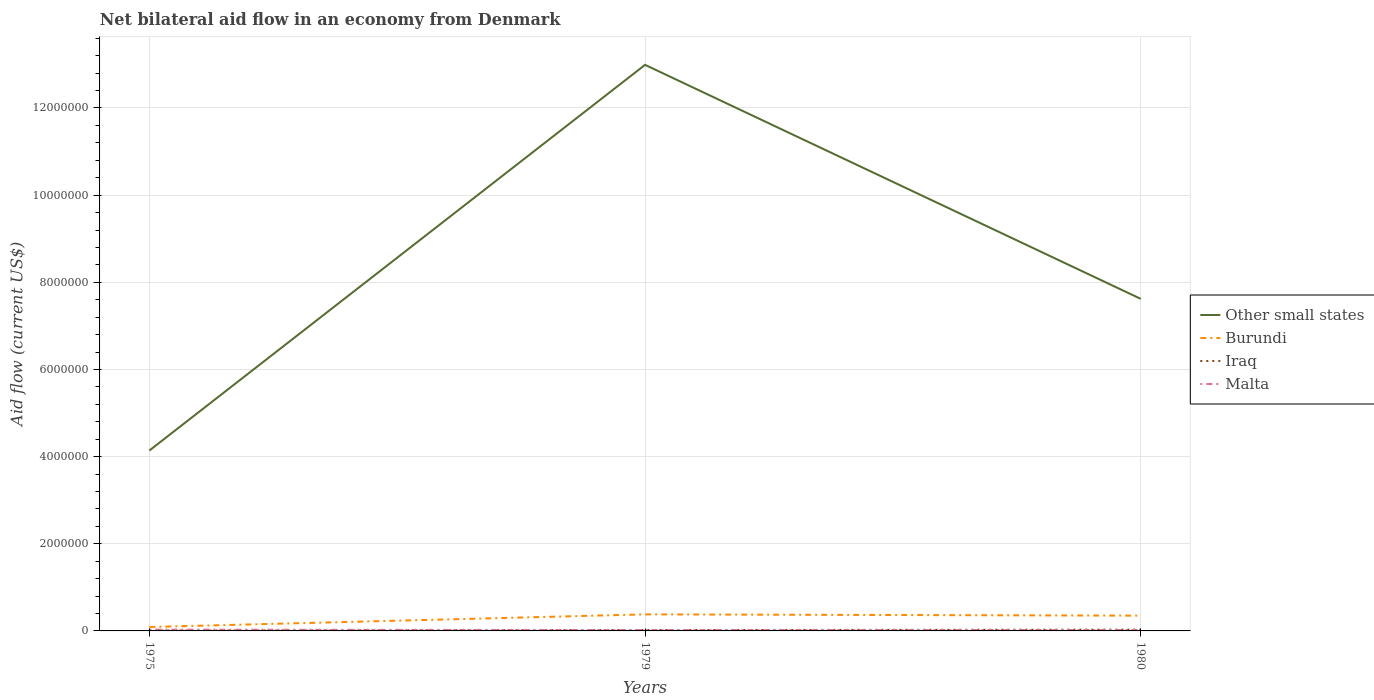How many different coloured lines are there?
Provide a short and direct response. 4. Is the number of lines equal to the number of legend labels?
Your answer should be compact. Yes. Across all years, what is the maximum net bilateral aid flow in Other small states?
Ensure brevity in your answer.  4.14e+06. In which year was the net bilateral aid flow in Burundi maximum?
Provide a succinct answer. 1975. What is the difference between the highest and the second highest net bilateral aid flow in Other small states?
Ensure brevity in your answer.  8.85e+06. Is the net bilateral aid flow in Burundi strictly greater than the net bilateral aid flow in Iraq over the years?
Provide a succinct answer. No. Are the values on the major ticks of Y-axis written in scientific E-notation?
Provide a succinct answer. No. Where does the legend appear in the graph?
Ensure brevity in your answer.  Center right. How many legend labels are there?
Offer a very short reply. 4. What is the title of the graph?
Give a very brief answer. Net bilateral aid flow in an economy from Denmark. What is the label or title of the X-axis?
Ensure brevity in your answer.  Years. What is the label or title of the Y-axis?
Offer a terse response. Aid flow (current US$). What is the Aid flow (current US$) of Other small states in 1975?
Keep it short and to the point. 4.14e+06. What is the Aid flow (current US$) of Burundi in 1975?
Make the answer very short. 9.00e+04. What is the Aid flow (current US$) in Iraq in 1975?
Make the answer very short. 10000. What is the Aid flow (current US$) of Malta in 1975?
Offer a terse response. 3.00e+04. What is the Aid flow (current US$) of Other small states in 1979?
Provide a succinct answer. 1.30e+07. What is the Aid flow (current US$) in Burundi in 1979?
Give a very brief answer. 3.80e+05. What is the Aid flow (current US$) of Iraq in 1979?
Provide a short and direct response. 2.00e+04. What is the Aid flow (current US$) of Other small states in 1980?
Offer a terse response. 7.62e+06. What is the Aid flow (current US$) of Burundi in 1980?
Offer a very short reply. 3.50e+05. Across all years, what is the maximum Aid flow (current US$) of Other small states?
Your answer should be compact. 1.30e+07. Across all years, what is the minimum Aid flow (current US$) of Other small states?
Provide a succinct answer. 4.14e+06. Across all years, what is the minimum Aid flow (current US$) of Burundi?
Offer a terse response. 9.00e+04. Across all years, what is the minimum Aid flow (current US$) in Iraq?
Make the answer very short. 10000. Across all years, what is the minimum Aid flow (current US$) in Malta?
Provide a succinct answer. 2.00e+04. What is the total Aid flow (current US$) in Other small states in the graph?
Offer a very short reply. 2.48e+07. What is the total Aid flow (current US$) in Burundi in the graph?
Ensure brevity in your answer.  8.20e+05. What is the difference between the Aid flow (current US$) of Other small states in 1975 and that in 1979?
Keep it short and to the point. -8.85e+06. What is the difference between the Aid flow (current US$) of Burundi in 1975 and that in 1979?
Keep it short and to the point. -2.90e+05. What is the difference between the Aid flow (current US$) of Iraq in 1975 and that in 1979?
Make the answer very short. -10000. What is the difference between the Aid flow (current US$) of Malta in 1975 and that in 1979?
Provide a short and direct response. 10000. What is the difference between the Aid flow (current US$) of Other small states in 1975 and that in 1980?
Give a very brief answer. -3.48e+06. What is the difference between the Aid flow (current US$) in Burundi in 1975 and that in 1980?
Your answer should be very brief. -2.60e+05. What is the difference between the Aid flow (current US$) in Iraq in 1975 and that in 1980?
Your response must be concise. -2.00e+04. What is the difference between the Aid flow (current US$) of Malta in 1975 and that in 1980?
Keep it short and to the point. 10000. What is the difference between the Aid flow (current US$) in Other small states in 1979 and that in 1980?
Your response must be concise. 5.37e+06. What is the difference between the Aid flow (current US$) of Burundi in 1979 and that in 1980?
Make the answer very short. 3.00e+04. What is the difference between the Aid flow (current US$) of Other small states in 1975 and the Aid flow (current US$) of Burundi in 1979?
Make the answer very short. 3.76e+06. What is the difference between the Aid flow (current US$) of Other small states in 1975 and the Aid flow (current US$) of Iraq in 1979?
Offer a terse response. 4.12e+06. What is the difference between the Aid flow (current US$) in Other small states in 1975 and the Aid flow (current US$) in Malta in 1979?
Provide a short and direct response. 4.12e+06. What is the difference between the Aid flow (current US$) of Burundi in 1975 and the Aid flow (current US$) of Iraq in 1979?
Provide a short and direct response. 7.00e+04. What is the difference between the Aid flow (current US$) of Burundi in 1975 and the Aid flow (current US$) of Malta in 1979?
Ensure brevity in your answer.  7.00e+04. What is the difference between the Aid flow (current US$) of Iraq in 1975 and the Aid flow (current US$) of Malta in 1979?
Offer a very short reply. -10000. What is the difference between the Aid flow (current US$) of Other small states in 1975 and the Aid flow (current US$) of Burundi in 1980?
Offer a terse response. 3.79e+06. What is the difference between the Aid flow (current US$) in Other small states in 1975 and the Aid flow (current US$) in Iraq in 1980?
Make the answer very short. 4.11e+06. What is the difference between the Aid flow (current US$) of Other small states in 1975 and the Aid flow (current US$) of Malta in 1980?
Offer a very short reply. 4.12e+06. What is the difference between the Aid flow (current US$) in Burundi in 1975 and the Aid flow (current US$) in Iraq in 1980?
Offer a terse response. 6.00e+04. What is the difference between the Aid flow (current US$) of Burundi in 1975 and the Aid flow (current US$) of Malta in 1980?
Make the answer very short. 7.00e+04. What is the difference between the Aid flow (current US$) of Other small states in 1979 and the Aid flow (current US$) of Burundi in 1980?
Your answer should be compact. 1.26e+07. What is the difference between the Aid flow (current US$) in Other small states in 1979 and the Aid flow (current US$) in Iraq in 1980?
Keep it short and to the point. 1.30e+07. What is the difference between the Aid flow (current US$) of Other small states in 1979 and the Aid flow (current US$) of Malta in 1980?
Provide a succinct answer. 1.30e+07. What is the difference between the Aid flow (current US$) in Burundi in 1979 and the Aid flow (current US$) in Iraq in 1980?
Give a very brief answer. 3.50e+05. What is the difference between the Aid flow (current US$) in Burundi in 1979 and the Aid flow (current US$) in Malta in 1980?
Provide a short and direct response. 3.60e+05. What is the average Aid flow (current US$) in Other small states per year?
Your response must be concise. 8.25e+06. What is the average Aid flow (current US$) of Burundi per year?
Offer a very short reply. 2.73e+05. What is the average Aid flow (current US$) in Iraq per year?
Offer a terse response. 2.00e+04. What is the average Aid flow (current US$) in Malta per year?
Offer a terse response. 2.33e+04. In the year 1975, what is the difference between the Aid flow (current US$) in Other small states and Aid flow (current US$) in Burundi?
Your answer should be very brief. 4.05e+06. In the year 1975, what is the difference between the Aid flow (current US$) in Other small states and Aid flow (current US$) in Iraq?
Provide a succinct answer. 4.13e+06. In the year 1975, what is the difference between the Aid flow (current US$) of Other small states and Aid flow (current US$) of Malta?
Your response must be concise. 4.11e+06. In the year 1975, what is the difference between the Aid flow (current US$) in Iraq and Aid flow (current US$) in Malta?
Give a very brief answer. -2.00e+04. In the year 1979, what is the difference between the Aid flow (current US$) in Other small states and Aid flow (current US$) in Burundi?
Give a very brief answer. 1.26e+07. In the year 1979, what is the difference between the Aid flow (current US$) in Other small states and Aid flow (current US$) in Iraq?
Offer a very short reply. 1.30e+07. In the year 1979, what is the difference between the Aid flow (current US$) in Other small states and Aid flow (current US$) in Malta?
Make the answer very short. 1.30e+07. In the year 1979, what is the difference between the Aid flow (current US$) in Burundi and Aid flow (current US$) in Malta?
Ensure brevity in your answer.  3.60e+05. In the year 1979, what is the difference between the Aid flow (current US$) of Iraq and Aid flow (current US$) of Malta?
Give a very brief answer. 0. In the year 1980, what is the difference between the Aid flow (current US$) of Other small states and Aid flow (current US$) of Burundi?
Make the answer very short. 7.27e+06. In the year 1980, what is the difference between the Aid flow (current US$) of Other small states and Aid flow (current US$) of Iraq?
Provide a short and direct response. 7.59e+06. In the year 1980, what is the difference between the Aid flow (current US$) of Other small states and Aid flow (current US$) of Malta?
Keep it short and to the point. 7.60e+06. In the year 1980, what is the difference between the Aid flow (current US$) of Burundi and Aid flow (current US$) of Iraq?
Provide a short and direct response. 3.20e+05. What is the ratio of the Aid flow (current US$) of Other small states in 1975 to that in 1979?
Your answer should be very brief. 0.32. What is the ratio of the Aid flow (current US$) of Burundi in 1975 to that in 1979?
Your answer should be compact. 0.24. What is the ratio of the Aid flow (current US$) in Malta in 1975 to that in 1979?
Make the answer very short. 1.5. What is the ratio of the Aid flow (current US$) of Other small states in 1975 to that in 1980?
Offer a very short reply. 0.54. What is the ratio of the Aid flow (current US$) of Burundi in 1975 to that in 1980?
Ensure brevity in your answer.  0.26. What is the ratio of the Aid flow (current US$) in Iraq in 1975 to that in 1980?
Your answer should be very brief. 0.33. What is the ratio of the Aid flow (current US$) in Other small states in 1979 to that in 1980?
Make the answer very short. 1.7. What is the ratio of the Aid flow (current US$) of Burundi in 1979 to that in 1980?
Your answer should be very brief. 1.09. What is the difference between the highest and the second highest Aid flow (current US$) in Other small states?
Provide a short and direct response. 5.37e+06. What is the difference between the highest and the second highest Aid flow (current US$) of Burundi?
Give a very brief answer. 3.00e+04. What is the difference between the highest and the lowest Aid flow (current US$) of Other small states?
Provide a short and direct response. 8.85e+06. What is the difference between the highest and the lowest Aid flow (current US$) in Malta?
Ensure brevity in your answer.  10000. 